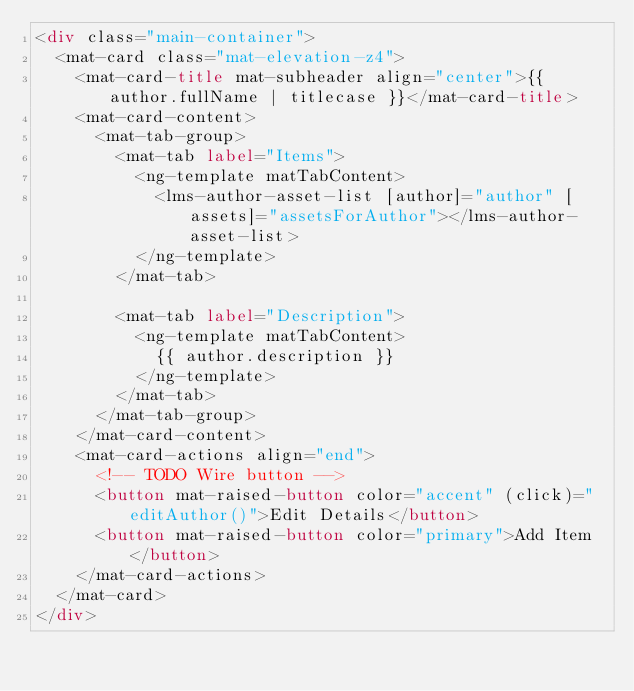<code> <loc_0><loc_0><loc_500><loc_500><_HTML_><div class="main-container">
  <mat-card class="mat-elevation-z4">
    <mat-card-title mat-subheader align="center">{{ author.fullName | titlecase }}</mat-card-title>
    <mat-card-content>
      <mat-tab-group>
        <mat-tab label="Items">
          <ng-template matTabContent>
            <lms-author-asset-list [author]="author" [assets]="assetsForAuthor"></lms-author-asset-list>
          </ng-template>
        </mat-tab>

        <mat-tab label="Description">
          <ng-template matTabContent>
            {{ author.description }}
          </ng-template>
        </mat-tab>
      </mat-tab-group>
    </mat-card-content>
    <mat-card-actions align="end">
      <!-- TODO Wire button -->
      <button mat-raised-button color="accent" (click)="editAuthor()">Edit Details</button>
      <button mat-raised-button color="primary">Add Item</button>
    </mat-card-actions>
  </mat-card>
</div>
</code> 